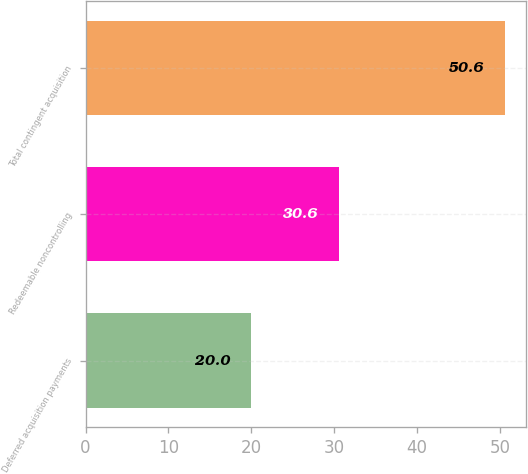<chart> <loc_0><loc_0><loc_500><loc_500><bar_chart><fcel>Deferred acquisition payments<fcel>Redeemable noncontrolling<fcel>Total contingent acquisition<nl><fcel>20<fcel>30.6<fcel>50.6<nl></chart> 